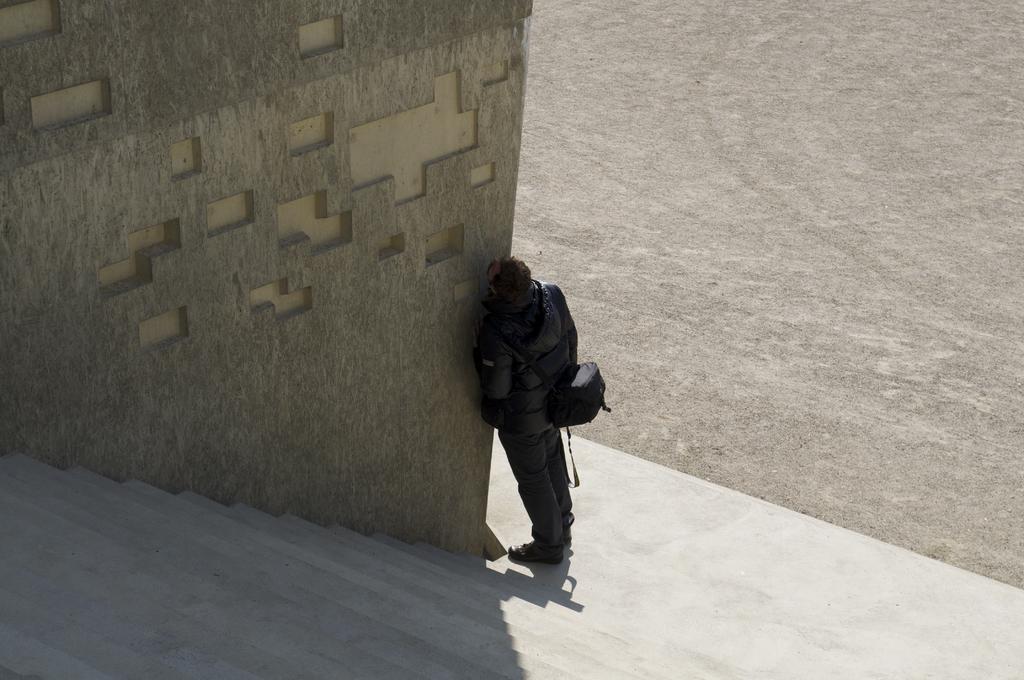Describe this image in one or two sentences. In this image there is a person wearing bag is standing beside the wall where we can see there are some stairs, on the other side there is a ground. 